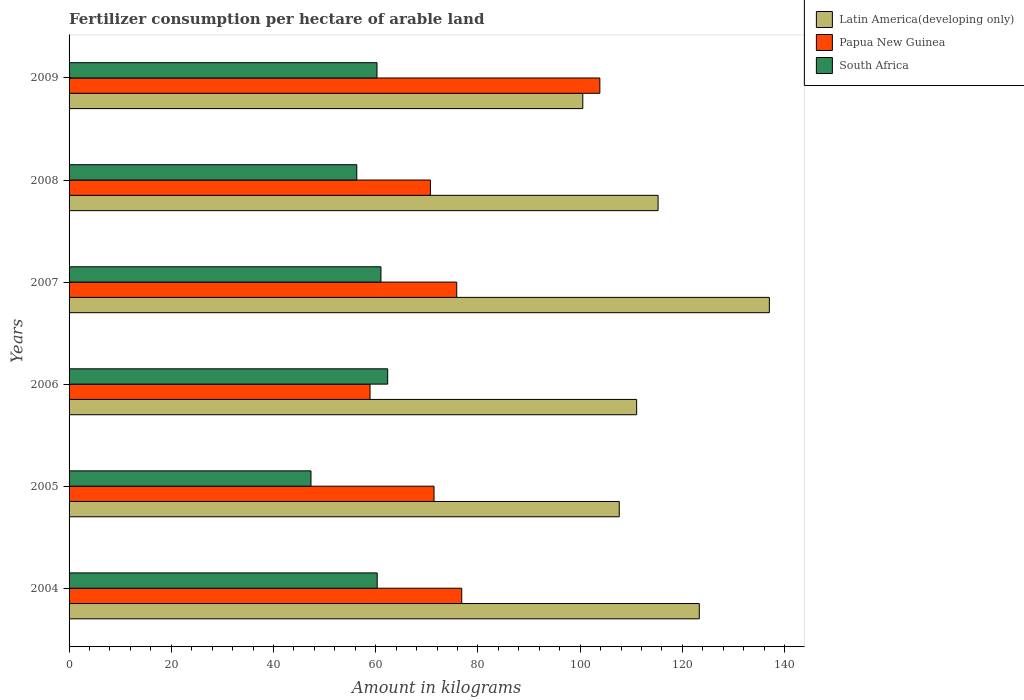How many different coloured bars are there?
Your answer should be very brief. 3. Are the number of bars per tick equal to the number of legend labels?
Give a very brief answer. Yes. How many bars are there on the 1st tick from the bottom?
Provide a succinct answer. 3. What is the label of the 1st group of bars from the top?
Offer a very short reply. 2009. In how many cases, is the number of bars for a given year not equal to the number of legend labels?
Offer a terse response. 0. What is the amount of fertilizer consumption in Papua New Guinea in 2006?
Your answer should be very brief. 58.89. Across all years, what is the maximum amount of fertilizer consumption in Papua New Guinea?
Ensure brevity in your answer.  103.85. Across all years, what is the minimum amount of fertilizer consumption in South Africa?
Provide a short and direct response. 47.33. In which year was the amount of fertilizer consumption in South Africa maximum?
Ensure brevity in your answer.  2006. In which year was the amount of fertilizer consumption in Latin America(developing only) minimum?
Provide a short and direct response. 2009. What is the total amount of fertilizer consumption in South Africa in the graph?
Keep it short and to the point. 347.52. What is the difference between the amount of fertilizer consumption in Papua New Guinea in 2005 and that in 2008?
Offer a very short reply. 0.7. What is the difference between the amount of fertilizer consumption in Latin America(developing only) in 2006 and the amount of fertilizer consumption in South Africa in 2008?
Offer a very short reply. 54.76. What is the average amount of fertilizer consumption in Latin America(developing only) per year?
Ensure brevity in your answer.  115.8. In the year 2005, what is the difference between the amount of fertilizer consumption in Papua New Guinea and amount of fertilizer consumption in Latin America(developing only)?
Give a very brief answer. -36.24. What is the ratio of the amount of fertilizer consumption in Latin America(developing only) in 2004 to that in 2005?
Your response must be concise. 1.15. Is the amount of fertilizer consumption in Latin America(developing only) in 2006 less than that in 2009?
Your answer should be very brief. No. What is the difference between the highest and the second highest amount of fertilizer consumption in South Africa?
Offer a terse response. 1.31. What is the difference between the highest and the lowest amount of fertilizer consumption in Papua New Guinea?
Offer a terse response. 44.97. In how many years, is the amount of fertilizer consumption in Papua New Guinea greater than the average amount of fertilizer consumption in Papua New Guinea taken over all years?
Your answer should be compact. 2. What does the 2nd bar from the top in 2008 represents?
Your answer should be compact. Papua New Guinea. What does the 2nd bar from the bottom in 2009 represents?
Offer a terse response. Papua New Guinea. Is it the case that in every year, the sum of the amount of fertilizer consumption in South Africa and amount of fertilizer consumption in Latin America(developing only) is greater than the amount of fertilizer consumption in Papua New Guinea?
Keep it short and to the point. Yes. How many bars are there?
Provide a succinct answer. 18. Are all the bars in the graph horizontal?
Your answer should be compact. Yes. What is the difference between two consecutive major ticks on the X-axis?
Give a very brief answer. 20. Does the graph contain any zero values?
Your response must be concise. No. Does the graph contain grids?
Keep it short and to the point. No. Where does the legend appear in the graph?
Offer a terse response. Top right. How many legend labels are there?
Your answer should be compact. 3. How are the legend labels stacked?
Ensure brevity in your answer.  Vertical. What is the title of the graph?
Offer a terse response. Fertilizer consumption per hectare of arable land. Does "Peru" appear as one of the legend labels in the graph?
Offer a very short reply. No. What is the label or title of the X-axis?
Your answer should be compact. Amount in kilograms. What is the label or title of the Y-axis?
Your answer should be compact. Years. What is the Amount in kilograms in Latin America(developing only) in 2004?
Ensure brevity in your answer.  123.31. What is the Amount in kilograms in Papua New Guinea in 2004?
Your response must be concise. 76.83. What is the Amount in kilograms in South Africa in 2004?
Make the answer very short. 60.29. What is the Amount in kilograms in Latin America(developing only) in 2005?
Keep it short and to the point. 107.65. What is the Amount in kilograms in Papua New Guinea in 2005?
Your response must be concise. 71.41. What is the Amount in kilograms in South Africa in 2005?
Keep it short and to the point. 47.33. What is the Amount in kilograms in Latin America(developing only) in 2006?
Your answer should be very brief. 111.05. What is the Amount in kilograms in Papua New Guinea in 2006?
Offer a very short reply. 58.89. What is the Amount in kilograms of South Africa in 2006?
Your answer should be very brief. 62.34. What is the Amount in kilograms of Latin America(developing only) in 2007?
Your response must be concise. 137.02. What is the Amount in kilograms of Papua New Guinea in 2007?
Your answer should be very brief. 75.85. What is the Amount in kilograms of South Africa in 2007?
Your answer should be very brief. 61.02. What is the Amount in kilograms in Latin America(developing only) in 2008?
Keep it short and to the point. 115.25. What is the Amount in kilograms of Papua New Guinea in 2008?
Give a very brief answer. 70.7. What is the Amount in kilograms in South Africa in 2008?
Provide a short and direct response. 56.29. What is the Amount in kilograms of Latin America(developing only) in 2009?
Offer a terse response. 100.52. What is the Amount in kilograms of Papua New Guinea in 2009?
Provide a succinct answer. 103.85. What is the Amount in kilograms of South Africa in 2009?
Offer a very short reply. 60.25. Across all years, what is the maximum Amount in kilograms of Latin America(developing only)?
Your response must be concise. 137.02. Across all years, what is the maximum Amount in kilograms of Papua New Guinea?
Your response must be concise. 103.85. Across all years, what is the maximum Amount in kilograms in South Africa?
Keep it short and to the point. 62.34. Across all years, what is the minimum Amount in kilograms in Latin America(developing only)?
Your answer should be compact. 100.52. Across all years, what is the minimum Amount in kilograms of Papua New Guinea?
Provide a succinct answer. 58.89. Across all years, what is the minimum Amount in kilograms of South Africa?
Your answer should be compact. 47.33. What is the total Amount in kilograms of Latin America(developing only) in the graph?
Your answer should be compact. 694.78. What is the total Amount in kilograms in Papua New Guinea in the graph?
Keep it short and to the point. 457.53. What is the total Amount in kilograms in South Africa in the graph?
Ensure brevity in your answer.  347.52. What is the difference between the Amount in kilograms in Latin America(developing only) in 2004 and that in 2005?
Make the answer very short. 15.66. What is the difference between the Amount in kilograms of Papua New Guinea in 2004 and that in 2005?
Make the answer very short. 5.42. What is the difference between the Amount in kilograms of South Africa in 2004 and that in 2005?
Your response must be concise. 12.96. What is the difference between the Amount in kilograms in Latin America(developing only) in 2004 and that in 2006?
Your response must be concise. 12.26. What is the difference between the Amount in kilograms in Papua New Guinea in 2004 and that in 2006?
Your answer should be compact. 17.94. What is the difference between the Amount in kilograms in South Africa in 2004 and that in 2006?
Make the answer very short. -2.05. What is the difference between the Amount in kilograms in Latin America(developing only) in 2004 and that in 2007?
Your response must be concise. -13.71. What is the difference between the Amount in kilograms of Papua New Guinea in 2004 and that in 2007?
Offer a terse response. 0.98. What is the difference between the Amount in kilograms in South Africa in 2004 and that in 2007?
Your answer should be very brief. -0.73. What is the difference between the Amount in kilograms in Latin America(developing only) in 2004 and that in 2008?
Your answer should be compact. 8.06. What is the difference between the Amount in kilograms of Papua New Guinea in 2004 and that in 2008?
Your answer should be compact. 6.12. What is the difference between the Amount in kilograms in South Africa in 2004 and that in 2008?
Offer a very short reply. 3.99. What is the difference between the Amount in kilograms of Latin America(developing only) in 2004 and that in 2009?
Provide a succinct answer. 22.79. What is the difference between the Amount in kilograms of Papua New Guinea in 2004 and that in 2009?
Your response must be concise. -27.03. What is the difference between the Amount in kilograms in South Africa in 2004 and that in 2009?
Offer a terse response. 0.04. What is the difference between the Amount in kilograms of Latin America(developing only) in 2005 and that in 2006?
Give a very brief answer. -3.4. What is the difference between the Amount in kilograms of Papua New Guinea in 2005 and that in 2006?
Make the answer very short. 12.52. What is the difference between the Amount in kilograms of South Africa in 2005 and that in 2006?
Provide a succinct answer. -15.01. What is the difference between the Amount in kilograms in Latin America(developing only) in 2005 and that in 2007?
Make the answer very short. -29.37. What is the difference between the Amount in kilograms in Papua New Guinea in 2005 and that in 2007?
Your response must be concise. -4.44. What is the difference between the Amount in kilograms of South Africa in 2005 and that in 2007?
Your response must be concise. -13.69. What is the difference between the Amount in kilograms of Latin America(developing only) in 2005 and that in 2008?
Your answer should be compact. -7.6. What is the difference between the Amount in kilograms in Papua New Guinea in 2005 and that in 2008?
Offer a very short reply. 0.7. What is the difference between the Amount in kilograms of South Africa in 2005 and that in 2008?
Make the answer very short. -8.96. What is the difference between the Amount in kilograms of Latin America(developing only) in 2005 and that in 2009?
Ensure brevity in your answer.  7.13. What is the difference between the Amount in kilograms of Papua New Guinea in 2005 and that in 2009?
Your answer should be compact. -32.45. What is the difference between the Amount in kilograms in South Africa in 2005 and that in 2009?
Keep it short and to the point. -12.92. What is the difference between the Amount in kilograms of Latin America(developing only) in 2006 and that in 2007?
Your response must be concise. -25.97. What is the difference between the Amount in kilograms of Papua New Guinea in 2006 and that in 2007?
Your answer should be compact. -16.96. What is the difference between the Amount in kilograms in South Africa in 2006 and that in 2007?
Give a very brief answer. 1.31. What is the difference between the Amount in kilograms in Latin America(developing only) in 2006 and that in 2008?
Make the answer very short. -4.2. What is the difference between the Amount in kilograms of Papua New Guinea in 2006 and that in 2008?
Offer a terse response. -11.82. What is the difference between the Amount in kilograms in South Africa in 2006 and that in 2008?
Give a very brief answer. 6.04. What is the difference between the Amount in kilograms of Latin America(developing only) in 2006 and that in 2009?
Your response must be concise. 10.53. What is the difference between the Amount in kilograms of Papua New Guinea in 2006 and that in 2009?
Keep it short and to the point. -44.97. What is the difference between the Amount in kilograms in South Africa in 2006 and that in 2009?
Ensure brevity in your answer.  2.09. What is the difference between the Amount in kilograms of Latin America(developing only) in 2007 and that in 2008?
Make the answer very short. 21.77. What is the difference between the Amount in kilograms in Papua New Guinea in 2007 and that in 2008?
Your answer should be compact. 5.14. What is the difference between the Amount in kilograms of South Africa in 2007 and that in 2008?
Offer a terse response. 4.73. What is the difference between the Amount in kilograms of Latin America(developing only) in 2007 and that in 2009?
Provide a short and direct response. 36.5. What is the difference between the Amount in kilograms of Papua New Guinea in 2007 and that in 2009?
Provide a succinct answer. -28.01. What is the difference between the Amount in kilograms in South Africa in 2007 and that in 2009?
Your answer should be very brief. 0.77. What is the difference between the Amount in kilograms of Latin America(developing only) in 2008 and that in 2009?
Offer a terse response. 14.73. What is the difference between the Amount in kilograms of Papua New Guinea in 2008 and that in 2009?
Provide a short and direct response. -33.15. What is the difference between the Amount in kilograms in South Africa in 2008 and that in 2009?
Provide a short and direct response. -3.95. What is the difference between the Amount in kilograms in Latin America(developing only) in 2004 and the Amount in kilograms in Papua New Guinea in 2005?
Give a very brief answer. 51.9. What is the difference between the Amount in kilograms of Latin America(developing only) in 2004 and the Amount in kilograms of South Africa in 2005?
Offer a very short reply. 75.98. What is the difference between the Amount in kilograms of Papua New Guinea in 2004 and the Amount in kilograms of South Africa in 2005?
Provide a succinct answer. 29.5. What is the difference between the Amount in kilograms of Latin America(developing only) in 2004 and the Amount in kilograms of Papua New Guinea in 2006?
Your answer should be compact. 64.42. What is the difference between the Amount in kilograms of Latin America(developing only) in 2004 and the Amount in kilograms of South Africa in 2006?
Give a very brief answer. 60.97. What is the difference between the Amount in kilograms in Papua New Guinea in 2004 and the Amount in kilograms in South Africa in 2006?
Give a very brief answer. 14.49. What is the difference between the Amount in kilograms in Latin America(developing only) in 2004 and the Amount in kilograms in Papua New Guinea in 2007?
Keep it short and to the point. 47.46. What is the difference between the Amount in kilograms in Latin America(developing only) in 2004 and the Amount in kilograms in South Africa in 2007?
Provide a succinct answer. 62.29. What is the difference between the Amount in kilograms in Papua New Guinea in 2004 and the Amount in kilograms in South Africa in 2007?
Give a very brief answer. 15.8. What is the difference between the Amount in kilograms of Latin America(developing only) in 2004 and the Amount in kilograms of Papua New Guinea in 2008?
Give a very brief answer. 52.61. What is the difference between the Amount in kilograms in Latin America(developing only) in 2004 and the Amount in kilograms in South Africa in 2008?
Keep it short and to the point. 67.02. What is the difference between the Amount in kilograms of Papua New Guinea in 2004 and the Amount in kilograms of South Africa in 2008?
Provide a short and direct response. 20.53. What is the difference between the Amount in kilograms of Latin America(developing only) in 2004 and the Amount in kilograms of Papua New Guinea in 2009?
Keep it short and to the point. 19.46. What is the difference between the Amount in kilograms of Latin America(developing only) in 2004 and the Amount in kilograms of South Africa in 2009?
Provide a succinct answer. 63.06. What is the difference between the Amount in kilograms in Papua New Guinea in 2004 and the Amount in kilograms in South Africa in 2009?
Offer a terse response. 16.58. What is the difference between the Amount in kilograms in Latin America(developing only) in 2005 and the Amount in kilograms in Papua New Guinea in 2006?
Make the answer very short. 48.76. What is the difference between the Amount in kilograms of Latin America(developing only) in 2005 and the Amount in kilograms of South Africa in 2006?
Offer a terse response. 45.31. What is the difference between the Amount in kilograms of Papua New Guinea in 2005 and the Amount in kilograms of South Africa in 2006?
Give a very brief answer. 9.07. What is the difference between the Amount in kilograms in Latin America(developing only) in 2005 and the Amount in kilograms in Papua New Guinea in 2007?
Keep it short and to the point. 31.8. What is the difference between the Amount in kilograms of Latin America(developing only) in 2005 and the Amount in kilograms of South Africa in 2007?
Your answer should be compact. 46.63. What is the difference between the Amount in kilograms in Papua New Guinea in 2005 and the Amount in kilograms in South Africa in 2007?
Provide a succinct answer. 10.39. What is the difference between the Amount in kilograms of Latin America(developing only) in 2005 and the Amount in kilograms of Papua New Guinea in 2008?
Give a very brief answer. 36.95. What is the difference between the Amount in kilograms in Latin America(developing only) in 2005 and the Amount in kilograms in South Africa in 2008?
Your answer should be compact. 51.36. What is the difference between the Amount in kilograms in Papua New Guinea in 2005 and the Amount in kilograms in South Africa in 2008?
Your answer should be very brief. 15.12. What is the difference between the Amount in kilograms in Latin America(developing only) in 2005 and the Amount in kilograms in Papua New Guinea in 2009?
Make the answer very short. 3.8. What is the difference between the Amount in kilograms in Latin America(developing only) in 2005 and the Amount in kilograms in South Africa in 2009?
Your answer should be compact. 47.4. What is the difference between the Amount in kilograms of Papua New Guinea in 2005 and the Amount in kilograms of South Africa in 2009?
Your response must be concise. 11.16. What is the difference between the Amount in kilograms of Latin America(developing only) in 2006 and the Amount in kilograms of Papua New Guinea in 2007?
Make the answer very short. 35.2. What is the difference between the Amount in kilograms of Latin America(developing only) in 2006 and the Amount in kilograms of South Africa in 2007?
Provide a short and direct response. 50.03. What is the difference between the Amount in kilograms of Papua New Guinea in 2006 and the Amount in kilograms of South Africa in 2007?
Give a very brief answer. -2.13. What is the difference between the Amount in kilograms in Latin America(developing only) in 2006 and the Amount in kilograms in Papua New Guinea in 2008?
Your answer should be compact. 40.35. What is the difference between the Amount in kilograms of Latin America(developing only) in 2006 and the Amount in kilograms of South Africa in 2008?
Offer a very short reply. 54.76. What is the difference between the Amount in kilograms of Papua New Guinea in 2006 and the Amount in kilograms of South Africa in 2008?
Your answer should be very brief. 2.59. What is the difference between the Amount in kilograms of Latin America(developing only) in 2006 and the Amount in kilograms of Papua New Guinea in 2009?
Offer a terse response. 7.2. What is the difference between the Amount in kilograms in Latin America(developing only) in 2006 and the Amount in kilograms in South Africa in 2009?
Keep it short and to the point. 50.8. What is the difference between the Amount in kilograms in Papua New Guinea in 2006 and the Amount in kilograms in South Africa in 2009?
Your answer should be compact. -1.36. What is the difference between the Amount in kilograms in Latin America(developing only) in 2007 and the Amount in kilograms in Papua New Guinea in 2008?
Ensure brevity in your answer.  66.31. What is the difference between the Amount in kilograms in Latin America(developing only) in 2007 and the Amount in kilograms in South Africa in 2008?
Provide a succinct answer. 80.72. What is the difference between the Amount in kilograms of Papua New Guinea in 2007 and the Amount in kilograms of South Africa in 2008?
Your answer should be compact. 19.55. What is the difference between the Amount in kilograms of Latin America(developing only) in 2007 and the Amount in kilograms of Papua New Guinea in 2009?
Keep it short and to the point. 33.16. What is the difference between the Amount in kilograms of Latin America(developing only) in 2007 and the Amount in kilograms of South Africa in 2009?
Provide a short and direct response. 76.77. What is the difference between the Amount in kilograms in Papua New Guinea in 2007 and the Amount in kilograms in South Africa in 2009?
Provide a succinct answer. 15.6. What is the difference between the Amount in kilograms of Latin America(developing only) in 2008 and the Amount in kilograms of Papua New Guinea in 2009?
Offer a terse response. 11.39. What is the difference between the Amount in kilograms of Latin America(developing only) in 2008 and the Amount in kilograms of South Africa in 2009?
Make the answer very short. 55. What is the difference between the Amount in kilograms of Papua New Guinea in 2008 and the Amount in kilograms of South Africa in 2009?
Make the answer very short. 10.46. What is the average Amount in kilograms in Latin America(developing only) per year?
Provide a short and direct response. 115.8. What is the average Amount in kilograms of Papua New Guinea per year?
Keep it short and to the point. 76.25. What is the average Amount in kilograms in South Africa per year?
Provide a short and direct response. 57.92. In the year 2004, what is the difference between the Amount in kilograms in Latin America(developing only) and Amount in kilograms in Papua New Guinea?
Make the answer very short. 46.48. In the year 2004, what is the difference between the Amount in kilograms of Latin America(developing only) and Amount in kilograms of South Africa?
Your answer should be compact. 63.02. In the year 2004, what is the difference between the Amount in kilograms in Papua New Guinea and Amount in kilograms in South Africa?
Your response must be concise. 16.54. In the year 2005, what is the difference between the Amount in kilograms of Latin America(developing only) and Amount in kilograms of Papua New Guinea?
Offer a terse response. 36.24. In the year 2005, what is the difference between the Amount in kilograms in Latin America(developing only) and Amount in kilograms in South Africa?
Your answer should be compact. 60.32. In the year 2005, what is the difference between the Amount in kilograms in Papua New Guinea and Amount in kilograms in South Africa?
Provide a short and direct response. 24.08. In the year 2006, what is the difference between the Amount in kilograms in Latin America(developing only) and Amount in kilograms in Papua New Guinea?
Offer a very short reply. 52.16. In the year 2006, what is the difference between the Amount in kilograms in Latin America(developing only) and Amount in kilograms in South Africa?
Keep it short and to the point. 48.71. In the year 2006, what is the difference between the Amount in kilograms of Papua New Guinea and Amount in kilograms of South Africa?
Your answer should be compact. -3.45. In the year 2007, what is the difference between the Amount in kilograms in Latin America(developing only) and Amount in kilograms in Papua New Guinea?
Provide a short and direct response. 61.17. In the year 2007, what is the difference between the Amount in kilograms of Latin America(developing only) and Amount in kilograms of South Africa?
Your response must be concise. 75.99. In the year 2007, what is the difference between the Amount in kilograms in Papua New Guinea and Amount in kilograms in South Africa?
Offer a very short reply. 14.83. In the year 2008, what is the difference between the Amount in kilograms in Latin America(developing only) and Amount in kilograms in Papua New Guinea?
Your answer should be compact. 44.54. In the year 2008, what is the difference between the Amount in kilograms in Latin America(developing only) and Amount in kilograms in South Africa?
Ensure brevity in your answer.  58.95. In the year 2008, what is the difference between the Amount in kilograms of Papua New Guinea and Amount in kilograms of South Africa?
Give a very brief answer. 14.41. In the year 2009, what is the difference between the Amount in kilograms of Latin America(developing only) and Amount in kilograms of Papua New Guinea?
Provide a short and direct response. -3.34. In the year 2009, what is the difference between the Amount in kilograms of Latin America(developing only) and Amount in kilograms of South Africa?
Ensure brevity in your answer.  40.27. In the year 2009, what is the difference between the Amount in kilograms in Papua New Guinea and Amount in kilograms in South Africa?
Give a very brief answer. 43.61. What is the ratio of the Amount in kilograms in Latin America(developing only) in 2004 to that in 2005?
Make the answer very short. 1.15. What is the ratio of the Amount in kilograms in Papua New Guinea in 2004 to that in 2005?
Your answer should be very brief. 1.08. What is the ratio of the Amount in kilograms of South Africa in 2004 to that in 2005?
Provide a short and direct response. 1.27. What is the ratio of the Amount in kilograms of Latin America(developing only) in 2004 to that in 2006?
Your answer should be compact. 1.11. What is the ratio of the Amount in kilograms of Papua New Guinea in 2004 to that in 2006?
Offer a very short reply. 1.3. What is the ratio of the Amount in kilograms in South Africa in 2004 to that in 2006?
Provide a succinct answer. 0.97. What is the ratio of the Amount in kilograms of Latin America(developing only) in 2004 to that in 2007?
Your answer should be compact. 0.9. What is the ratio of the Amount in kilograms in Papua New Guinea in 2004 to that in 2007?
Your answer should be very brief. 1.01. What is the ratio of the Amount in kilograms of South Africa in 2004 to that in 2007?
Your answer should be compact. 0.99. What is the ratio of the Amount in kilograms of Latin America(developing only) in 2004 to that in 2008?
Give a very brief answer. 1.07. What is the ratio of the Amount in kilograms in Papua New Guinea in 2004 to that in 2008?
Offer a terse response. 1.09. What is the ratio of the Amount in kilograms of South Africa in 2004 to that in 2008?
Provide a short and direct response. 1.07. What is the ratio of the Amount in kilograms of Latin America(developing only) in 2004 to that in 2009?
Your answer should be compact. 1.23. What is the ratio of the Amount in kilograms of Papua New Guinea in 2004 to that in 2009?
Offer a very short reply. 0.74. What is the ratio of the Amount in kilograms of South Africa in 2004 to that in 2009?
Ensure brevity in your answer.  1. What is the ratio of the Amount in kilograms of Latin America(developing only) in 2005 to that in 2006?
Provide a succinct answer. 0.97. What is the ratio of the Amount in kilograms in Papua New Guinea in 2005 to that in 2006?
Keep it short and to the point. 1.21. What is the ratio of the Amount in kilograms in South Africa in 2005 to that in 2006?
Your answer should be very brief. 0.76. What is the ratio of the Amount in kilograms in Latin America(developing only) in 2005 to that in 2007?
Offer a very short reply. 0.79. What is the ratio of the Amount in kilograms in Papua New Guinea in 2005 to that in 2007?
Give a very brief answer. 0.94. What is the ratio of the Amount in kilograms in South Africa in 2005 to that in 2007?
Your answer should be very brief. 0.78. What is the ratio of the Amount in kilograms of Latin America(developing only) in 2005 to that in 2008?
Provide a succinct answer. 0.93. What is the ratio of the Amount in kilograms of South Africa in 2005 to that in 2008?
Make the answer very short. 0.84. What is the ratio of the Amount in kilograms in Latin America(developing only) in 2005 to that in 2009?
Provide a short and direct response. 1.07. What is the ratio of the Amount in kilograms of Papua New Guinea in 2005 to that in 2009?
Your answer should be compact. 0.69. What is the ratio of the Amount in kilograms in South Africa in 2005 to that in 2009?
Give a very brief answer. 0.79. What is the ratio of the Amount in kilograms in Latin America(developing only) in 2006 to that in 2007?
Keep it short and to the point. 0.81. What is the ratio of the Amount in kilograms in Papua New Guinea in 2006 to that in 2007?
Give a very brief answer. 0.78. What is the ratio of the Amount in kilograms of South Africa in 2006 to that in 2007?
Keep it short and to the point. 1.02. What is the ratio of the Amount in kilograms of Latin America(developing only) in 2006 to that in 2008?
Your response must be concise. 0.96. What is the ratio of the Amount in kilograms of Papua New Guinea in 2006 to that in 2008?
Give a very brief answer. 0.83. What is the ratio of the Amount in kilograms in South Africa in 2006 to that in 2008?
Keep it short and to the point. 1.11. What is the ratio of the Amount in kilograms of Latin America(developing only) in 2006 to that in 2009?
Your answer should be compact. 1.1. What is the ratio of the Amount in kilograms of Papua New Guinea in 2006 to that in 2009?
Your answer should be very brief. 0.57. What is the ratio of the Amount in kilograms of South Africa in 2006 to that in 2009?
Provide a succinct answer. 1.03. What is the ratio of the Amount in kilograms of Latin America(developing only) in 2007 to that in 2008?
Give a very brief answer. 1.19. What is the ratio of the Amount in kilograms in Papua New Guinea in 2007 to that in 2008?
Ensure brevity in your answer.  1.07. What is the ratio of the Amount in kilograms in South Africa in 2007 to that in 2008?
Offer a terse response. 1.08. What is the ratio of the Amount in kilograms in Latin America(developing only) in 2007 to that in 2009?
Your answer should be compact. 1.36. What is the ratio of the Amount in kilograms in Papua New Guinea in 2007 to that in 2009?
Make the answer very short. 0.73. What is the ratio of the Amount in kilograms of South Africa in 2007 to that in 2009?
Make the answer very short. 1.01. What is the ratio of the Amount in kilograms in Latin America(developing only) in 2008 to that in 2009?
Keep it short and to the point. 1.15. What is the ratio of the Amount in kilograms in Papua New Guinea in 2008 to that in 2009?
Your response must be concise. 0.68. What is the ratio of the Amount in kilograms of South Africa in 2008 to that in 2009?
Provide a succinct answer. 0.93. What is the difference between the highest and the second highest Amount in kilograms in Latin America(developing only)?
Your response must be concise. 13.71. What is the difference between the highest and the second highest Amount in kilograms in Papua New Guinea?
Offer a terse response. 27.03. What is the difference between the highest and the second highest Amount in kilograms of South Africa?
Ensure brevity in your answer.  1.31. What is the difference between the highest and the lowest Amount in kilograms in Latin America(developing only)?
Your answer should be compact. 36.5. What is the difference between the highest and the lowest Amount in kilograms of Papua New Guinea?
Your answer should be very brief. 44.97. What is the difference between the highest and the lowest Amount in kilograms of South Africa?
Make the answer very short. 15.01. 